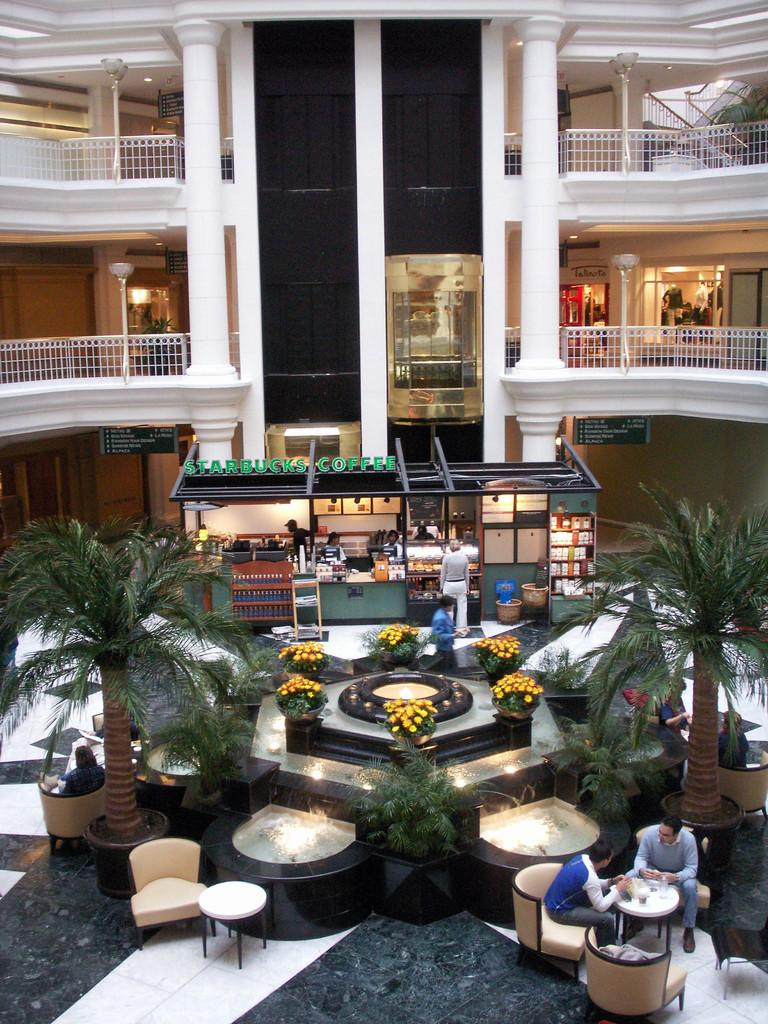<image>
Create a compact narrative representing the image presented. An atrium of what looks like an hotel.  On the farside there is a Starbucks Coffee outlet. 